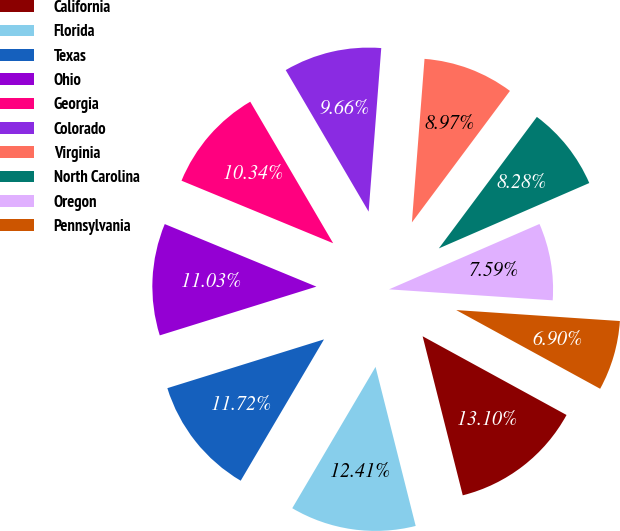<chart> <loc_0><loc_0><loc_500><loc_500><pie_chart><fcel>California<fcel>Florida<fcel>Texas<fcel>Ohio<fcel>Georgia<fcel>Colorado<fcel>Virginia<fcel>North Carolina<fcel>Oregon<fcel>Pennsylvania<nl><fcel>13.1%<fcel>12.41%<fcel>11.72%<fcel>11.03%<fcel>10.34%<fcel>9.66%<fcel>8.97%<fcel>8.28%<fcel>7.59%<fcel>6.9%<nl></chart> 